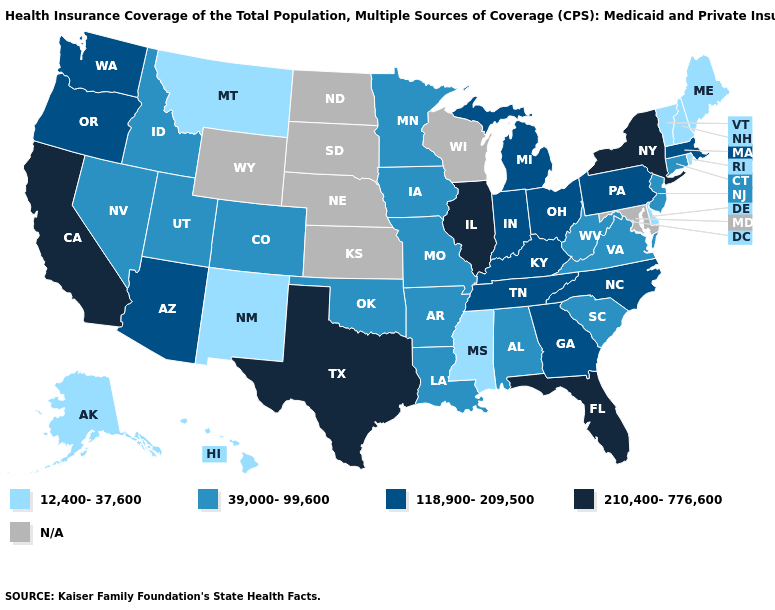What is the highest value in the MidWest ?
Quick response, please. 210,400-776,600. Does the map have missing data?
Concise answer only. Yes. Among the states that border North Dakota , which have the lowest value?
Keep it brief. Montana. Name the states that have a value in the range 39,000-99,600?
Keep it brief. Alabama, Arkansas, Colorado, Connecticut, Idaho, Iowa, Louisiana, Minnesota, Missouri, Nevada, New Jersey, Oklahoma, South Carolina, Utah, Virginia, West Virginia. Among the states that border North Dakota , which have the lowest value?
Short answer required. Montana. What is the value of Minnesota?
Answer briefly. 39,000-99,600. Name the states that have a value in the range 118,900-209,500?
Concise answer only. Arizona, Georgia, Indiana, Kentucky, Massachusetts, Michigan, North Carolina, Ohio, Oregon, Pennsylvania, Tennessee, Washington. Does New York have the highest value in the Northeast?
Answer briefly. Yes. What is the value of Rhode Island?
Quick response, please. 12,400-37,600. Name the states that have a value in the range 39,000-99,600?
Concise answer only. Alabama, Arkansas, Colorado, Connecticut, Idaho, Iowa, Louisiana, Minnesota, Missouri, Nevada, New Jersey, Oklahoma, South Carolina, Utah, Virginia, West Virginia. What is the value of Colorado?
Write a very short answer. 39,000-99,600. Among the states that border Ohio , which have the highest value?
Answer briefly. Indiana, Kentucky, Michigan, Pennsylvania. Does Florida have the highest value in the USA?
Concise answer only. Yes. 